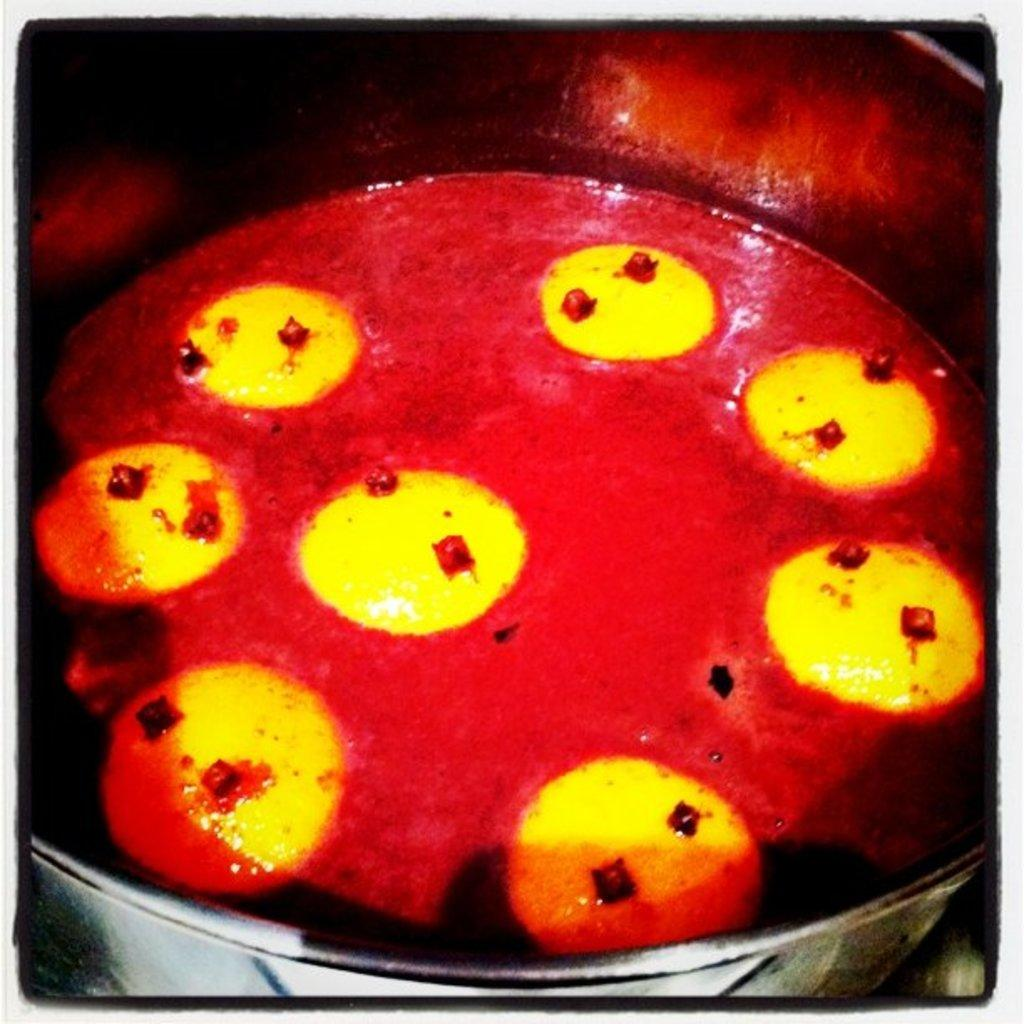What is the main object in the image? There is a vessel in the image. What is inside the vessel? There is a dish in the vessel. How many thumbs can be seen in the image? There are no thumbs visible in the image. What type of ball is being used in the image? There is no ball present in the image. 